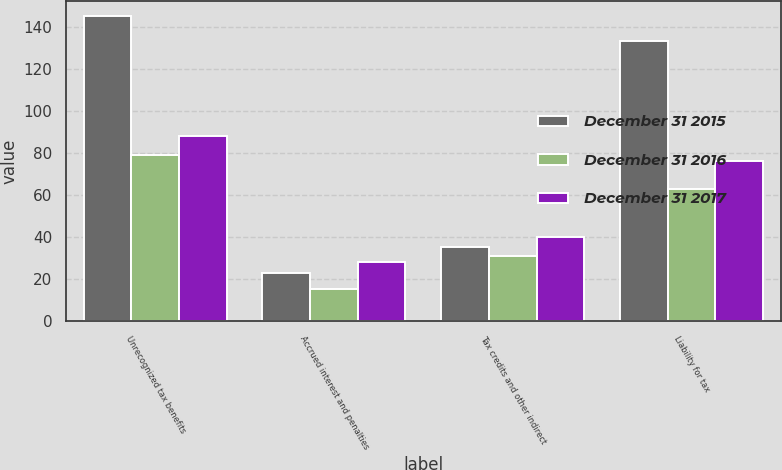<chart> <loc_0><loc_0><loc_500><loc_500><stacked_bar_chart><ecel><fcel>Unrecognized tax benefits<fcel>Accrued interest and penalties<fcel>Tax credits and other indirect<fcel>Liability for tax<nl><fcel>December 31 2015<fcel>145<fcel>23<fcel>35<fcel>133<nl><fcel>December 31 2016<fcel>79<fcel>15<fcel>31<fcel>63<nl><fcel>December 31 2017<fcel>88<fcel>28<fcel>40<fcel>76<nl></chart> 